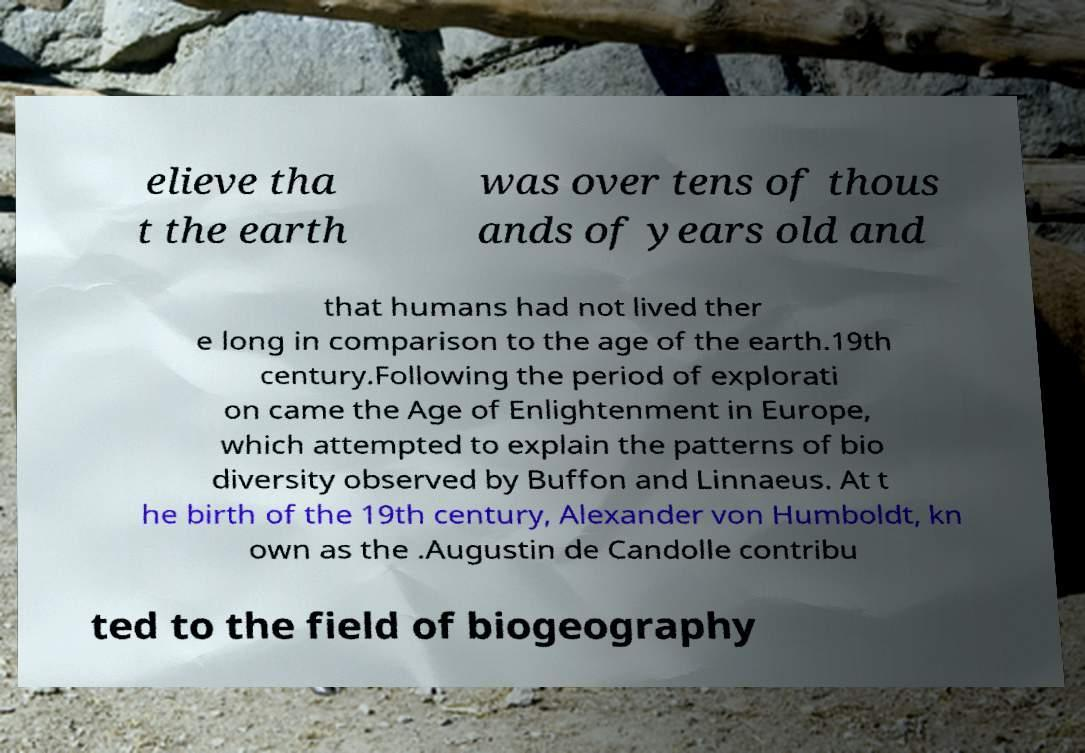For documentation purposes, I need the text within this image transcribed. Could you provide that? elieve tha t the earth was over tens of thous ands of years old and that humans had not lived ther e long in comparison to the age of the earth.19th century.Following the period of explorati on came the Age of Enlightenment in Europe, which attempted to explain the patterns of bio diversity observed by Buffon and Linnaeus. At t he birth of the 19th century, Alexander von Humboldt, kn own as the .Augustin de Candolle contribu ted to the field of biogeography 